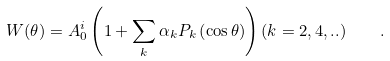Convert formula to latex. <formula><loc_0><loc_0><loc_500><loc_500>W ( \theta ) = A _ { 0 } ^ { i } \left ( 1 + \sum _ { k } \alpha _ { k } P _ { k } \left ( \cos \theta \right ) \right ) ( k = 2 , 4 , . . ) \quad .</formula> 